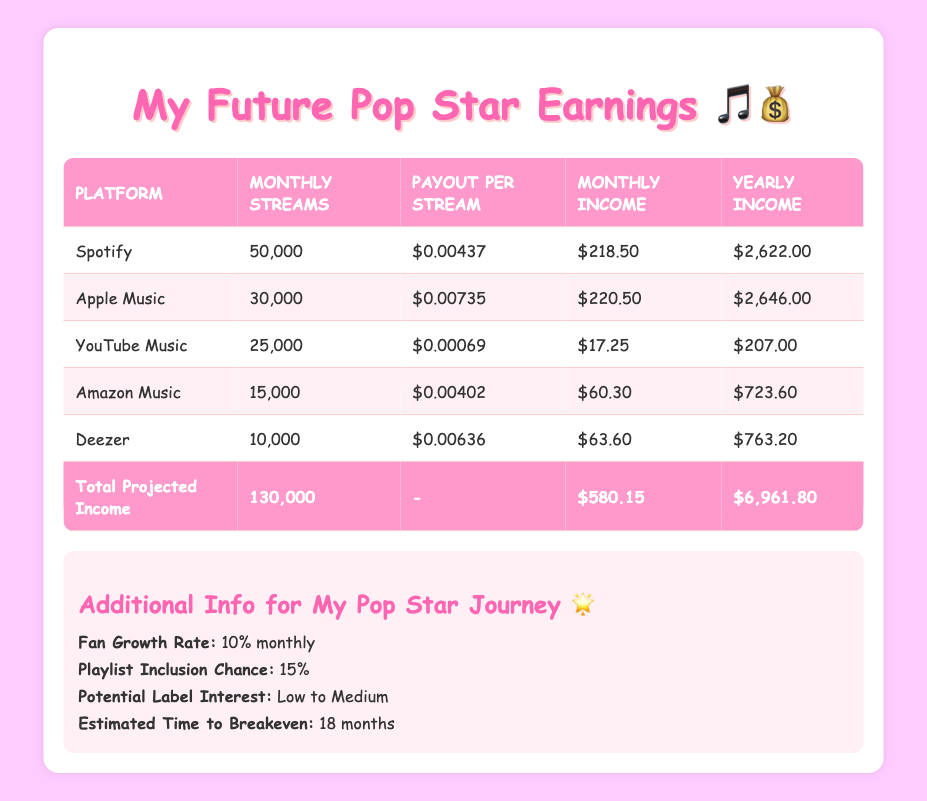What is the total projected income from music streaming platforms for the year? The total projected yearly income is listed at the bottom of the table under "Total Projected Income," which shows $6,961.80.
Answer: $6,961.80 Which platform has the highest monthly income? By comparing the monthly income values for each platform in the table, Apple Music has the highest monthly income of $220.50.
Answer: Apple Music What is the total number of projected monthly streams across all platforms? The total number of projected monthly streams is indicated in the last row of the table under "Total Projected Income," which shows 130,000 streams.
Answer: 130,000 Is the payout per stream for Deezer higher than that for YouTube Music? By comparing the payout per stream values, Deezer ($0.00636) is higher than YouTube Music ($0.00069).
Answer: Yes If I expect my fan base to grow by 10% monthly starting with 100 fans, how many fans will I have after three months? Starting with 100 fans, the growth after three months can be calculated using the formula: 
Month 1: 100 * 1.1 = 110
Month 2: 110 * 1.1 = 121
Month 3: 121 * 1.1 = 133.1, rounding gives approximately 133 fans. Thus, the answer is 133 fans.
Answer: 133 fans What is the monthly income from Spotify and Amazon Music combined? To find the combined monthly income, add the monthly incomes of Spotify ($218.50) and Amazon Music ($60.30): $218.50 + $60.30 = $278.80.
Answer: $278.80 Is the estimated time to breakeven more than a year? The estimated time to breakeven is stated as 18 months, which is more than one year (12 months).
Answer: Yes What is the average monthly income across all five streaming platforms? To calculate the average monthly income, sum the monthly incomes: $218.50 + $220.50 + $17.25 + $60.30 + $63.60 = $580.15. Then divide by the number of platforms (5): $580.15 / 5 = $116.03.
Answer: $116.03 